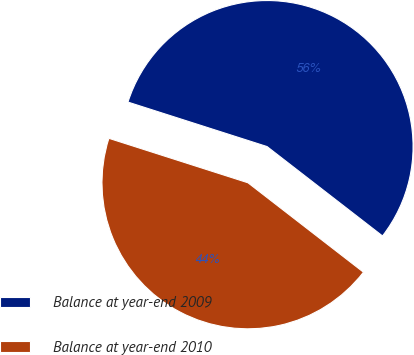Convert chart. <chart><loc_0><loc_0><loc_500><loc_500><pie_chart><fcel>Balance at year-end 2009<fcel>Balance at year-end 2010<nl><fcel>55.56%<fcel>44.44%<nl></chart> 